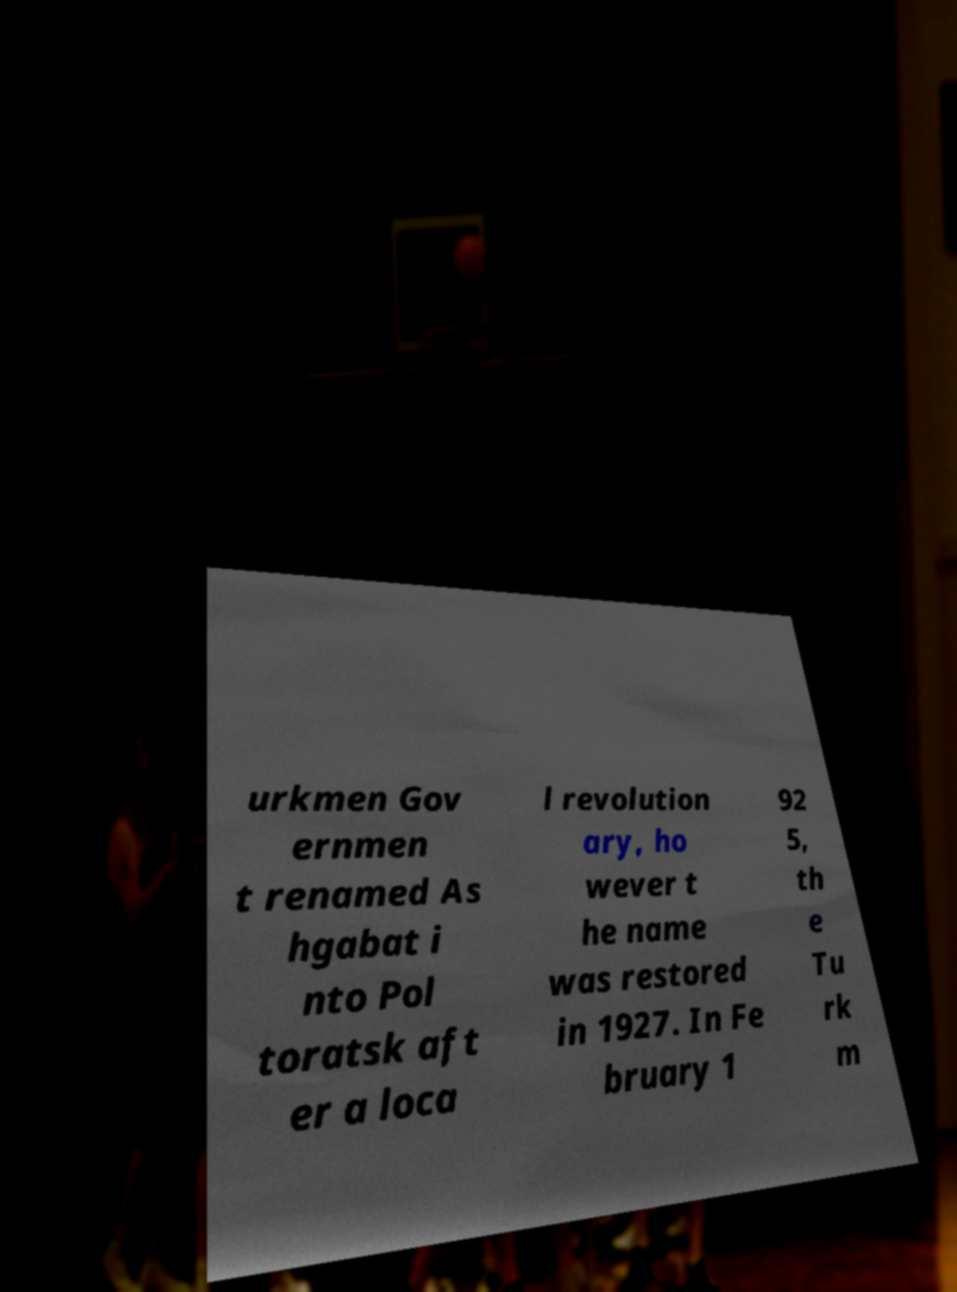Can you accurately transcribe the text from the provided image for me? urkmen Gov ernmen t renamed As hgabat i nto Pol toratsk aft er a loca l revolution ary, ho wever t he name was restored in 1927. In Fe bruary 1 92 5, th e Tu rk m 